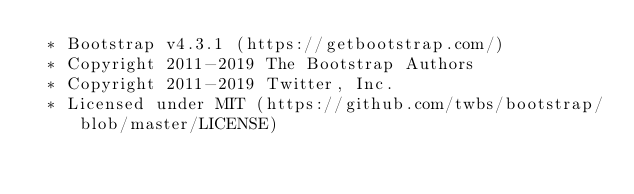<code> <loc_0><loc_0><loc_500><loc_500><_CSS_> * Bootstrap v4.3.1 (https://getbootstrap.com/)
 * Copyright 2011-2019 The Bootstrap Authors
 * Copyright 2011-2019 Twitter, Inc.
 * Licensed under MIT (https://github.com/twbs/bootstrap/blob/master/LICENSE)</code> 